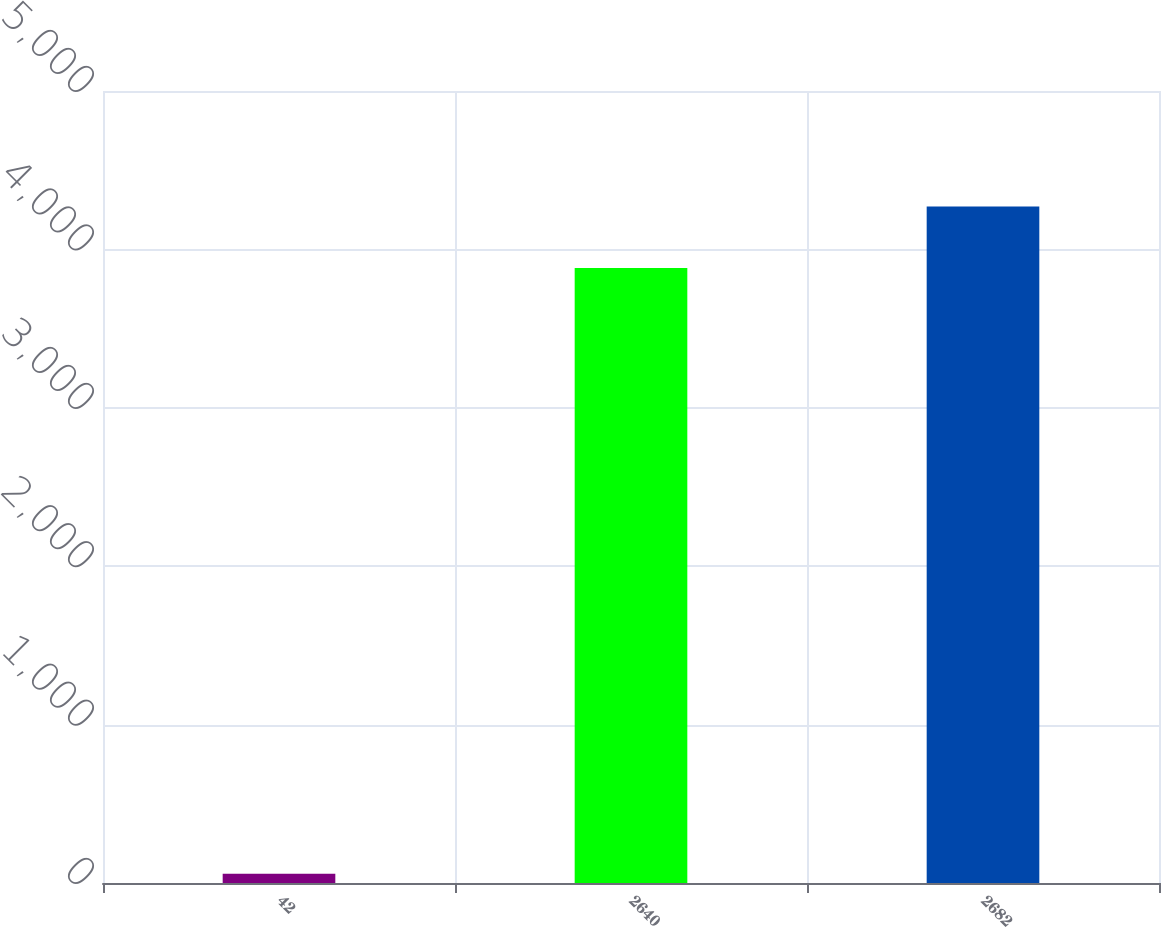<chart> <loc_0><loc_0><loc_500><loc_500><bar_chart><fcel>42<fcel>2640<fcel>2682<nl><fcel>58<fcel>3883<fcel>4271.3<nl></chart> 